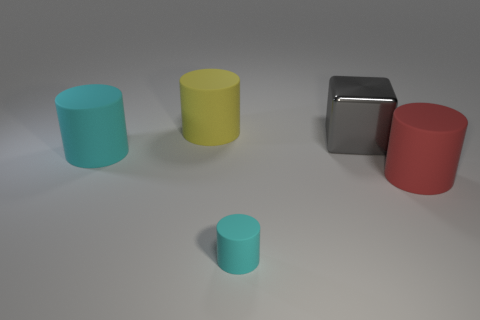Subtract all large red cylinders. How many cylinders are left? 3 Subtract all yellow cylinders. How many cylinders are left? 3 Add 1 big red matte things. How many objects exist? 6 Add 3 tiny cyan cylinders. How many tiny cyan cylinders exist? 4 Subtract 0 green cubes. How many objects are left? 5 Subtract all blocks. How many objects are left? 4 Subtract 4 cylinders. How many cylinders are left? 0 Subtract all gray cylinders. Subtract all green blocks. How many cylinders are left? 4 Subtract all purple cylinders. How many purple cubes are left? 0 Subtract all blue shiny cylinders. Subtract all red rubber things. How many objects are left? 4 